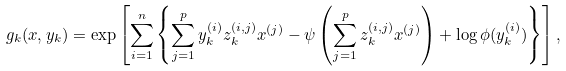Convert formula to latex. <formula><loc_0><loc_0><loc_500><loc_500>g _ { k } ( x , y _ { k } ) = \exp \left [ \sum _ { i = 1 } ^ { n } \left \{ \sum _ { j = 1 } ^ { p } y _ { k } ^ { ( i ) } z _ { k } ^ { ( i , j ) } x ^ { ( j ) } - \psi \left ( \sum _ { j = 1 } ^ { p } z _ { k } ^ { ( i , j ) } x ^ { ( j ) } \right ) + \log \phi ( y _ { k } ^ { ( i ) } ) \right \} \right ] ,</formula> 